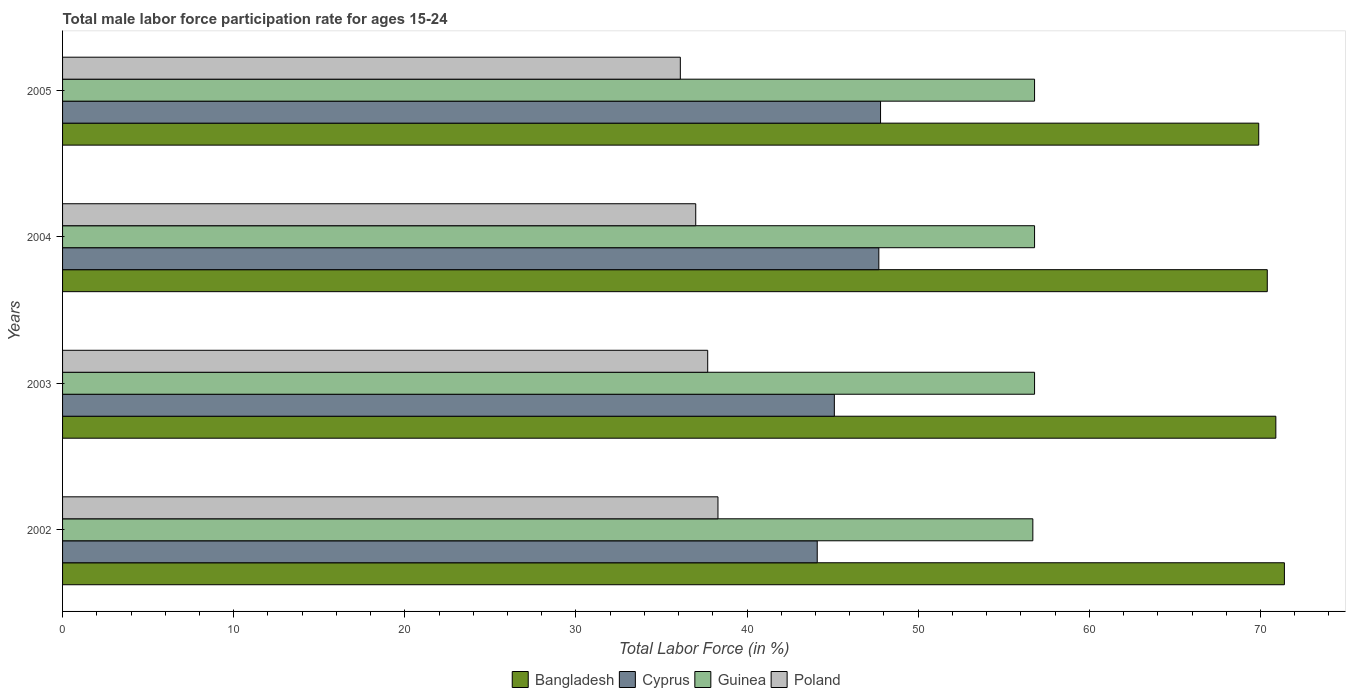How many different coloured bars are there?
Provide a short and direct response. 4. Are the number of bars per tick equal to the number of legend labels?
Give a very brief answer. Yes. How many bars are there on the 2nd tick from the top?
Your answer should be very brief. 4. What is the label of the 1st group of bars from the top?
Provide a short and direct response. 2005. What is the male labor force participation rate in Guinea in 2003?
Your response must be concise. 56.8. Across all years, what is the maximum male labor force participation rate in Cyprus?
Give a very brief answer. 47.8. Across all years, what is the minimum male labor force participation rate in Guinea?
Make the answer very short. 56.7. What is the total male labor force participation rate in Cyprus in the graph?
Your response must be concise. 184.7. What is the difference between the male labor force participation rate in Bangladesh in 2002 and that in 2003?
Your answer should be very brief. 0.5. What is the difference between the male labor force participation rate in Bangladesh in 2004 and the male labor force participation rate in Guinea in 2002?
Keep it short and to the point. 13.7. What is the average male labor force participation rate in Guinea per year?
Provide a short and direct response. 56.77. In the year 2003, what is the difference between the male labor force participation rate in Guinea and male labor force participation rate in Poland?
Provide a succinct answer. 19.1. In how many years, is the male labor force participation rate in Cyprus greater than 48 %?
Make the answer very short. 0. What is the ratio of the male labor force participation rate in Bangladesh in 2004 to that in 2005?
Provide a short and direct response. 1.01. Is the difference between the male labor force participation rate in Guinea in 2002 and 2003 greater than the difference between the male labor force participation rate in Poland in 2002 and 2003?
Provide a short and direct response. No. What is the difference between the highest and the second highest male labor force participation rate in Poland?
Offer a terse response. 0.6. What is the difference between the highest and the lowest male labor force participation rate in Guinea?
Your answer should be very brief. 0.1. What does the 2nd bar from the top in 2002 represents?
Your answer should be compact. Guinea. What does the 1st bar from the bottom in 2002 represents?
Your response must be concise. Bangladesh. Is it the case that in every year, the sum of the male labor force participation rate in Bangladesh and male labor force participation rate in Cyprus is greater than the male labor force participation rate in Guinea?
Offer a terse response. Yes. How many bars are there?
Your answer should be very brief. 16. Are all the bars in the graph horizontal?
Provide a succinct answer. Yes. How many years are there in the graph?
Your response must be concise. 4. Does the graph contain any zero values?
Ensure brevity in your answer.  No. Does the graph contain grids?
Your response must be concise. No. How many legend labels are there?
Offer a very short reply. 4. How are the legend labels stacked?
Your answer should be very brief. Horizontal. What is the title of the graph?
Your answer should be very brief. Total male labor force participation rate for ages 15-24. Does "Tanzania" appear as one of the legend labels in the graph?
Make the answer very short. No. What is the label or title of the X-axis?
Your answer should be compact. Total Labor Force (in %). What is the label or title of the Y-axis?
Your response must be concise. Years. What is the Total Labor Force (in %) of Bangladesh in 2002?
Provide a short and direct response. 71.4. What is the Total Labor Force (in %) in Cyprus in 2002?
Ensure brevity in your answer.  44.1. What is the Total Labor Force (in %) of Guinea in 2002?
Ensure brevity in your answer.  56.7. What is the Total Labor Force (in %) in Poland in 2002?
Offer a terse response. 38.3. What is the Total Labor Force (in %) in Bangladesh in 2003?
Offer a very short reply. 70.9. What is the Total Labor Force (in %) in Cyprus in 2003?
Give a very brief answer. 45.1. What is the Total Labor Force (in %) of Guinea in 2003?
Offer a terse response. 56.8. What is the Total Labor Force (in %) in Poland in 2003?
Ensure brevity in your answer.  37.7. What is the Total Labor Force (in %) of Bangladesh in 2004?
Your response must be concise. 70.4. What is the Total Labor Force (in %) in Cyprus in 2004?
Keep it short and to the point. 47.7. What is the Total Labor Force (in %) of Guinea in 2004?
Make the answer very short. 56.8. What is the Total Labor Force (in %) of Bangladesh in 2005?
Provide a succinct answer. 69.9. What is the Total Labor Force (in %) in Cyprus in 2005?
Your answer should be very brief. 47.8. What is the Total Labor Force (in %) in Guinea in 2005?
Provide a succinct answer. 56.8. What is the Total Labor Force (in %) in Poland in 2005?
Give a very brief answer. 36.1. Across all years, what is the maximum Total Labor Force (in %) in Bangladesh?
Provide a short and direct response. 71.4. Across all years, what is the maximum Total Labor Force (in %) in Cyprus?
Your response must be concise. 47.8. Across all years, what is the maximum Total Labor Force (in %) in Guinea?
Offer a very short reply. 56.8. Across all years, what is the maximum Total Labor Force (in %) in Poland?
Offer a very short reply. 38.3. Across all years, what is the minimum Total Labor Force (in %) of Bangladesh?
Provide a succinct answer. 69.9. Across all years, what is the minimum Total Labor Force (in %) of Cyprus?
Your response must be concise. 44.1. Across all years, what is the minimum Total Labor Force (in %) of Guinea?
Give a very brief answer. 56.7. Across all years, what is the minimum Total Labor Force (in %) in Poland?
Give a very brief answer. 36.1. What is the total Total Labor Force (in %) of Bangladesh in the graph?
Offer a very short reply. 282.6. What is the total Total Labor Force (in %) in Cyprus in the graph?
Your answer should be very brief. 184.7. What is the total Total Labor Force (in %) of Guinea in the graph?
Provide a succinct answer. 227.1. What is the total Total Labor Force (in %) of Poland in the graph?
Provide a succinct answer. 149.1. What is the difference between the Total Labor Force (in %) in Bangladesh in 2002 and that in 2004?
Offer a terse response. 1. What is the difference between the Total Labor Force (in %) of Guinea in 2002 and that in 2004?
Provide a short and direct response. -0.1. What is the difference between the Total Labor Force (in %) of Bangladesh in 2002 and that in 2005?
Give a very brief answer. 1.5. What is the difference between the Total Labor Force (in %) in Guinea in 2002 and that in 2005?
Your response must be concise. -0.1. What is the difference between the Total Labor Force (in %) in Cyprus in 2003 and that in 2004?
Provide a succinct answer. -2.6. What is the difference between the Total Labor Force (in %) in Cyprus in 2003 and that in 2005?
Your response must be concise. -2.7. What is the difference between the Total Labor Force (in %) of Poland in 2003 and that in 2005?
Provide a short and direct response. 1.6. What is the difference between the Total Labor Force (in %) of Cyprus in 2004 and that in 2005?
Give a very brief answer. -0.1. What is the difference between the Total Labor Force (in %) in Guinea in 2004 and that in 2005?
Provide a short and direct response. 0. What is the difference between the Total Labor Force (in %) of Bangladesh in 2002 and the Total Labor Force (in %) of Cyprus in 2003?
Your answer should be very brief. 26.3. What is the difference between the Total Labor Force (in %) in Bangladesh in 2002 and the Total Labor Force (in %) in Guinea in 2003?
Your answer should be very brief. 14.6. What is the difference between the Total Labor Force (in %) in Bangladesh in 2002 and the Total Labor Force (in %) in Poland in 2003?
Your answer should be very brief. 33.7. What is the difference between the Total Labor Force (in %) of Cyprus in 2002 and the Total Labor Force (in %) of Guinea in 2003?
Your answer should be compact. -12.7. What is the difference between the Total Labor Force (in %) in Cyprus in 2002 and the Total Labor Force (in %) in Poland in 2003?
Make the answer very short. 6.4. What is the difference between the Total Labor Force (in %) in Bangladesh in 2002 and the Total Labor Force (in %) in Cyprus in 2004?
Offer a terse response. 23.7. What is the difference between the Total Labor Force (in %) in Bangladesh in 2002 and the Total Labor Force (in %) in Guinea in 2004?
Your response must be concise. 14.6. What is the difference between the Total Labor Force (in %) in Bangladesh in 2002 and the Total Labor Force (in %) in Poland in 2004?
Your answer should be compact. 34.4. What is the difference between the Total Labor Force (in %) of Cyprus in 2002 and the Total Labor Force (in %) of Guinea in 2004?
Make the answer very short. -12.7. What is the difference between the Total Labor Force (in %) of Cyprus in 2002 and the Total Labor Force (in %) of Poland in 2004?
Your answer should be very brief. 7.1. What is the difference between the Total Labor Force (in %) in Guinea in 2002 and the Total Labor Force (in %) in Poland in 2004?
Give a very brief answer. 19.7. What is the difference between the Total Labor Force (in %) in Bangladesh in 2002 and the Total Labor Force (in %) in Cyprus in 2005?
Give a very brief answer. 23.6. What is the difference between the Total Labor Force (in %) in Bangladesh in 2002 and the Total Labor Force (in %) in Guinea in 2005?
Offer a terse response. 14.6. What is the difference between the Total Labor Force (in %) of Bangladesh in 2002 and the Total Labor Force (in %) of Poland in 2005?
Provide a succinct answer. 35.3. What is the difference between the Total Labor Force (in %) of Cyprus in 2002 and the Total Labor Force (in %) of Guinea in 2005?
Offer a terse response. -12.7. What is the difference between the Total Labor Force (in %) of Cyprus in 2002 and the Total Labor Force (in %) of Poland in 2005?
Ensure brevity in your answer.  8. What is the difference between the Total Labor Force (in %) of Guinea in 2002 and the Total Labor Force (in %) of Poland in 2005?
Your answer should be compact. 20.6. What is the difference between the Total Labor Force (in %) in Bangladesh in 2003 and the Total Labor Force (in %) in Cyprus in 2004?
Offer a very short reply. 23.2. What is the difference between the Total Labor Force (in %) of Bangladesh in 2003 and the Total Labor Force (in %) of Guinea in 2004?
Offer a terse response. 14.1. What is the difference between the Total Labor Force (in %) in Bangladesh in 2003 and the Total Labor Force (in %) in Poland in 2004?
Make the answer very short. 33.9. What is the difference between the Total Labor Force (in %) of Cyprus in 2003 and the Total Labor Force (in %) of Poland in 2004?
Provide a succinct answer. 8.1. What is the difference between the Total Labor Force (in %) of Guinea in 2003 and the Total Labor Force (in %) of Poland in 2004?
Provide a succinct answer. 19.8. What is the difference between the Total Labor Force (in %) in Bangladesh in 2003 and the Total Labor Force (in %) in Cyprus in 2005?
Give a very brief answer. 23.1. What is the difference between the Total Labor Force (in %) of Bangladesh in 2003 and the Total Labor Force (in %) of Guinea in 2005?
Keep it short and to the point. 14.1. What is the difference between the Total Labor Force (in %) of Bangladesh in 2003 and the Total Labor Force (in %) of Poland in 2005?
Your answer should be compact. 34.8. What is the difference between the Total Labor Force (in %) in Guinea in 2003 and the Total Labor Force (in %) in Poland in 2005?
Make the answer very short. 20.7. What is the difference between the Total Labor Force (in %) of Bangladesh in 2004 and the Total Labor Force (in %) of Cyprus in 2005?
Your response must be concise. 22.6. What is the difference between the Total Labor Force (in %) of Bangladesh in 2004 and the Total Labor Force (in %) of Poland in 2005?
Make the answer very short. 34.3. What is the difference between the Total Labor Force (in %) in Guinea in 2004 and the Total Labor Force (in %) in Poland in 2005?
Your answer should be very brief. 20.7. What is the average Total Labor Force (in %) in Bangladesh per year?
Ensure brevity in your answer.  70.65. What is the average Total Labor Force (in %) in Cyprus per year?
Your response must be concise. 46.17. What is the average Total Labor Force (in %) in Guinea per year?
Your answer should be very brief. 56.77. What is the average Total Labor Force (in %) of Poland per year?
Provide a short and direct response. 37.27. In the year 2002, what is the difference between the Total Labor Force (in %) of Bangladesh and Total Labor Force (in %) of Cyprus?
Your response must be concise. 27.3. In the year 2002, what is the difference between the Total Labor Force (in %) in Bangladesh and Total Labor Force (in %) in Guinea?
Provide a succinct answer. 14.7. In the year 2002, what is the difference between the Total Labor Force (in %) of Bangladesh and Total Labor Force (in %) of Poland?
Provide a short and direct response. 33.1. In the year 2002, what is the difference between the Total Labor Force (in %) in Cyprus and Total Labor Force (in %) in Guinea?
Your answer should be very brief. -12.6. In the year 2002, what is the difference between the Total Labor Force (in %) of Cyprus and Total Labor Force (in %) of Poland?
Your answer should be compact. 5.8. In the year 2003, what is the difference between the Total Labor Force (in %) in Bangladesh and Total Labor Force (in %) in Cyprus?
Offer a terse response. 25.8. In the year 2003, what is the difference between the Total Labor Force (in %) in Bangladesh and Total Labor Force (in %) in Poland?
Make the answer very short. 33.2. In the year 2003, what is the difference between the Total Labor Force (in %) of Cyprus and Total Labor Force (in %) of Guinea?
Provide a short and direct response. -11.7. In the year 2003, what is the difference between the Total Labor Force (in %) in Guinea and Total Labor Force (in %) in Poland?
Provide a short and direct response. 19.1. In the year 2004, what is the difference between the Total Labor Force (in %) in Bangladesh and Total Labor Force (in %) in Cyprus?
Your response must be concise. 22.7. In the year 2004, what is the difference between the Total Labor Force (in %) of Bangladesh and Total Labor Force (in %) of Poland?
Offer a terse response. 33.4. In the year 2004, what is the difference between the Total Labor Force (in %) in Cyprus and Total Labor Force (in %) in Guinea?
Give a very brief answer. -9.1. In the year 2004, what is the difference between the Total Labor Force (in %) of Guinea and Total Labor Force (in %) of Poland?
Keep it short and to the point. 19.8. In the year 2005, what is the difference between the Total Labor Force (in %) of Bangladesh and Total Labor Force (in %) of Cyprus?
Your answer should be very brief. 22.1. In the year 2005, what is the difference between the Total Labor Force (in %) in Bangladesh and Total Labor Force (in %) in Guinea?
Provide a succinct answer. 13.1. In the year 2005, what is the difference between the Total Labor Force (in %) in Bangladesh and Total Labor Force (in %) in Poland?
Keep it short and to the point. 33.8. In the year 2005, what is the difference between the Total Labor Force (in %) in Cyprus and Total Labor Force (in %) in Guinea?
Provide a succinct answer. -9. In the year 2005, what is the difference between the Total Labor Force (in %) in Cyprus and Total Labor Force (in %) in Poland?
Your response must be concise. 11.7. In the year 2005, what is the difference between the Total Labor Force (in %) in Guinea and Total Labor Force (in %) in Poland?
Your answer should be compact. 20.7. What is the ratio of the Total Labor Force (in %) of Bangladesh in 2002 to that in 2003?
Provide a succinct answer. 1.01. What is the ratio of the Total Labor Force (in %) of Cyprus in 2002 to that in 2003?
Make the answer very short. 0.98. What is the ratio of the Total Labor Force (in %) in Guinea in 2002 to that in 2003?
Your answer should be very brief. 1. What is the ratio of the Total Labor Force (in %) in Poland in 2002 to that in 2003?
Keep it short and to the point. 1.02. What is the ratio of the Total Labor Force (in %) in Bangladesh in 2002 to that in 2004?
Make the answer very short. 1.01. What is the ratio of the Total Labor Force (in %) of Cyprus in 2002 to that in 2004?
Provide a short and direct response. 0.92. What is the ratio of the Total Labor Force (in %) of Poland in 2002 to that in 2004?
Make the answer very short. 1.04. What is the ratio of the Total Labor Force (in %) of Bangladesh in 2002 to that in 2005?
Keep it short and to the point. 1.02. What is the ratio of the Total Labor Force (in %) in Cyprus in 2002 to that in 2005?
Your answer should be very brief. 0.92. What is the ratio of the Total Labor Force (in %) in Poland in 2002 to that in 2005?
Offer a terse response. 1.06. What is the ratio of the Total Labor Force (in %) in Bangladesh in 2003 to that in 2004?
Make the answer very short. 1.01. What is the ratio of the Total Labor Force (in %) of Cyprus in 2003 to that in 2004?
Your answer should be very brief. 0.95. What is the ratio of the Total Labor Force (in %) in Guinea in 2003 to that in 2004?
Your response must be concise. 1. What is the ratio of the Total Labor Force (in %) of Poland in 2003 to that in 2004?
Ensure brevity in your answer.  1.02. What is the ratio of the Total Labor Force (in %) in Bangladesh in 2003 to that in 2005?
Provide a succinct answer. 1.01. What is the ratio of the Total Labor Force (in %) of Cyprus in 2003 to that in 2005?
Keep it short and to the point. 0.94. What is the ratio of the Total Labor Force (in %) in Guinea in 2003 to that in 2005?
Your answer should be very brief. 1. What is the ratio of the Total Labor Force (in %) in Poland in 2003 to that in 2005?
Your answer should be very brief. 1.04. What is the ratio of the Total Labor Force (in %) of Cyprus in 2004 to that in 2005?
Ensure brevity in your answer.  1. What is the ratio of the Total Labor Force (in %) in Poland in 2004 to that in 2005?
Provide a succinct answer. 1.02. What is the difference between the highest and the second highest Total Labor Force (in %) of Guinea?
Keep it short and to the point. 0. What is the difference between the highest and the second highest Total Labor Force (in %) of Poland?
Keep it short and to the point. 0.6. What is the difference between the highest and the lowest Total Labor Force (in %) in Cyprus?
Give a very brief answer. 3.7. What is the difference between the highest and the lowest Total Labor Force (in %) in Guinea?
Offer a very short reply. 0.1. What is the difference between the highest and the lowest Total Labor Force (in %) of Poland?
Keep it short and to the point. 2.2. 